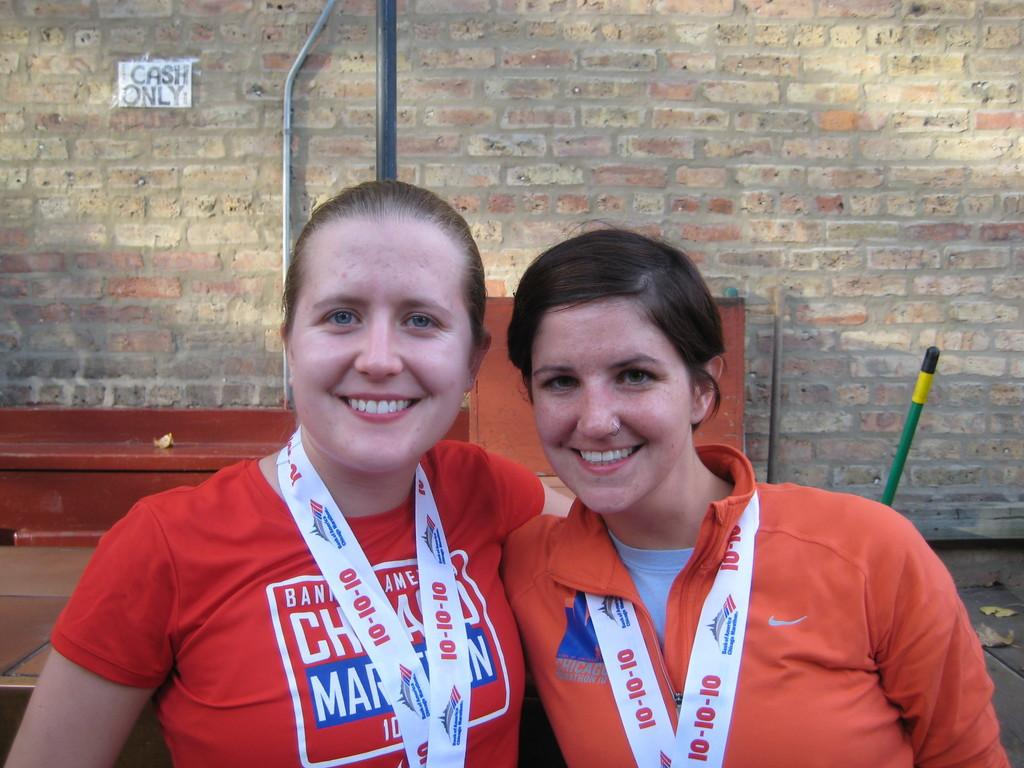<image>
Summarize the visual content of the image. Two women posing for a photo with one wearing a chain that has the number 10 on it. 